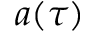Convert formula to latex. <formula><loc_0><loc_0><loc_500><loc_500>a ( \tau )</formula> 